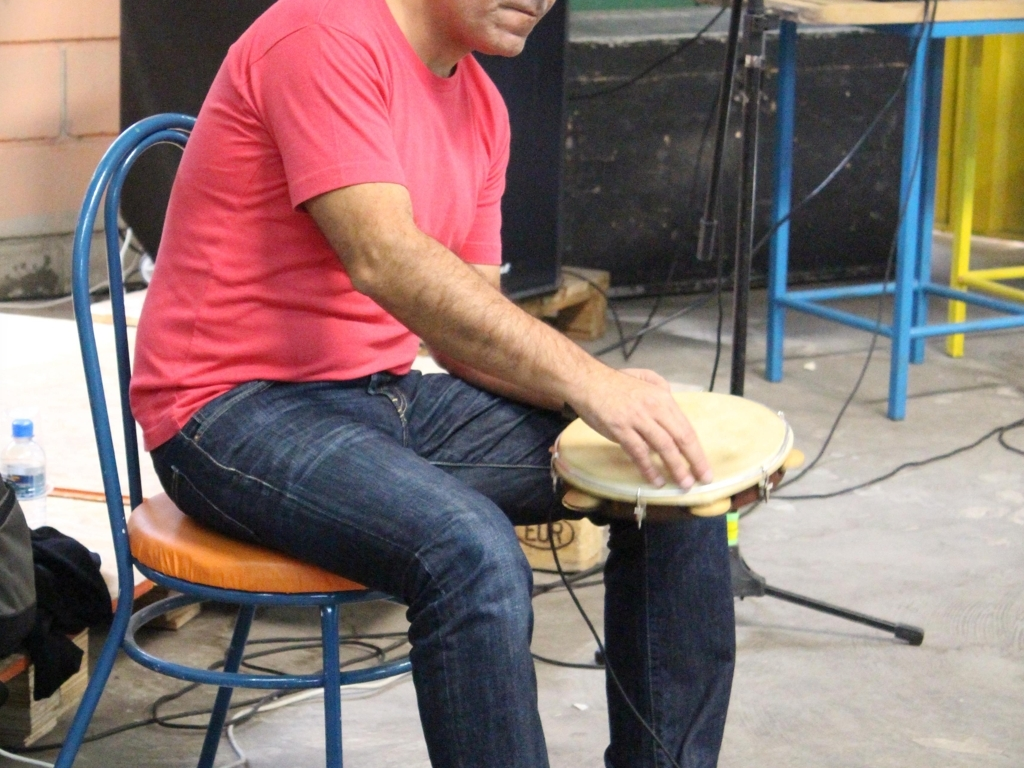Is the subject showing their full face? No, the subject is not showing their full face. The individual is captured from a side view making their full facial features not visible. 